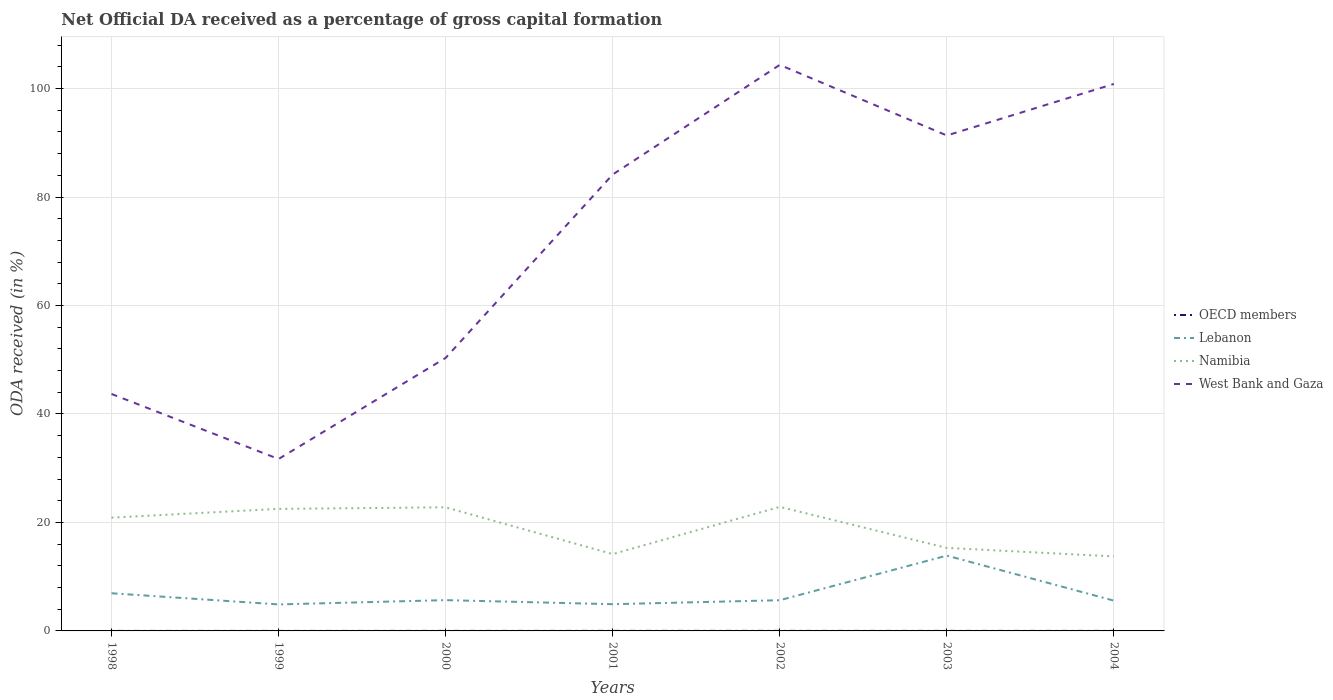How many different coloured lines are there?
Offer a very short reply. 4. Is the number of lines equal to the number of legend labels?
Offer a terse response. Yes. Across all years, what is the maximum net ODA received in OECD members?
Your response must be concise. 0. What is the total net ODA received in West Bank and Gaza in the graph?
Offer a very short reply. 3.51. What is the difference between the highest and the second highest net ODA received in Lebanon?
Keep it short and to the point. 9. Is the net ODA received in West Bank and Gaza strictly greater than the net ODA received in Lebanon over the years?
Provide a short and direct response. No. How many years are there in the graph?
Your response must be concise. 7. What is the difference between two consecutive major ticks on the Y-axis?
Ensure brevity in your answer.  20. Does the graph contain any zero values?
Your answer should be very brief. No. Does the graph contain grids?
Make the answer very short. Yes. Where does the legend appear in the graph?
Provide a short and direct response. Center right. How many legend labels are there?
Keep it short and to the point. 4. What is the title of the graph?
Your answer should be very brief. Net Official DA received as a percentage of gross capital formation. What is the label or title of the X-axis?
Provide a succinct answer. Years. What is the label or title of the Y-axis?
Your answer should be very brief. ODA received (in %). What is the ODA received (in %) in OECD members in 1998?
Make the answer very short. 0. What is the ODA received (in %) of Lebanon in 1998?
Give a very brief answer. 6.94. What is the ODA received (in %) in Namibia in 1998?
Your answer should be very brief. 20.89. What is the ODA received (in %) of West Bank and Gaza in 1998?
Offer a terse response. 43.69. What is the ODA received (in %) in OECD members in 1999?
Offer a terse response. 0. What is the ODA received (in %) of Lebanon in 1999?
Give a very brief answer. 4.88. What is the ODA received (in %) of Namibia in 1999?
Provide a short and direct response. 22.5. What is the ODA received (in %) of West Bank and Gaza in 1999?
Offer a terse response. 31.7. What is the ODA received (in %) in OECD members in 2000?
Provide a short and direct response. 0.01. What is the ODA received (in %) of Lebanon in 2000?
Your response must be concise. 5.68. What is the ODA received (in %) of Namibia in 2000?
Give a very brief answer. 22.79. What is the ODA received (in %) of West Bank and Gaza in 2000?
Your answer should be very brief. 50.34. What is the ODA received (in %) in OECD members in 2001?
Ensure brevity in your answer.  0.01. What is the ODA received (in %) of Lebanon in 2001?
Offer a very short reply. 4.93. What is the ODA received (in %) of Namibia in 2001?
Offer a terse response. 14.17. What is the ODA received (in %) of West Bank and Gaza in 2001?
Offer a very short reply. 84.16. What is the ODA received (in %) in OECD members in 2002?
Ensure brevity in your answer.  0.01. What is the ODA received (in %) of Lebanon in 2002?
Make the answer very short. 5.66. What is the ODA received (in %) of Namibia in 2002?
Your answer should be compact. 22.88. What is the ODA received (in %) of West Bank and Gaza in 2002?
Your response must be concise. 104.37. What is the ODA received (in %) of OECD members in 2003?
Provide a succinct answer. 0.01. What is the ODA received (in %) of Lebanon in 2003?
Your answer should be compact. 13.89. What is the ODA received (in %) in Namibia in 2003?
Keep it short and to the point. 15.3. What is the ODA received (in %) in West Bank and Gaza in 2003?
Keep it short and to the point. 91.35. What is the ODA received (in %) of OECD members in 2004?
Provide a succinct answer. 0.01. What is the ODA received (in %) in Lebanon in 2004?
Make the answer very short. 5.58. What is the ODA received (in %) in Namibia in 2004?
Offer a terse response. 13.74. What is the ODA received (in %) in West Bank and Gaza in 2004?
Offer a very short reply. 100.86. Across all years, what is the maximum ODA received (in %) in OECD members?
Give a very brief answer. 0.01. Across all years, what is the maximum ODA received (in %) of Lebanon?
Ensure brevity in your answer.  13.89. Across all years, what is the maximum ODA received (in %) of Namibia?
Your answer should be very brief. 22.88. Across all years, what is the maximum ODA received (in %) in West Bank and Gaza?
Make the answer very short. 104.37. Across all years, what is the minimum ODA received (in %) of OECD members?
Keep it short and to the point. 0. Across all years, what is the minimum ODA received (in %) in Lebanon?
Give a very brief answer. 4.88. Across all years, what is the minimum ODA received (in %) of Namibia?
Provide a short and direct response. 13.74. Across all years, what is the minimum ODA received (in %) in West Bank and Gaza?
Give a very brief answer. 31.7. What is the total ODA received (in %) of OECD members in the graph?
Keep it short and to the point. 0.04. What is the total ODA received (in %) in Lebanon in the graph?
Keep it short and to the point. 47.56. What is the total ODA received (in %) of Namibia in the graph?
Offer a very short reply. 132.27. What is the total ODA received (in %) of West Bank and Gaza in the graph?
Offer a terse response. 506.46. What is the difference between the ODA received (in %) of OECD members in 1998 and that in 1999?
Offer a very short reply. 0. What is the difference between the ODA received (in %) of Lebanon in 1998 and that in 1999?
Ensure brevity in your answer.  2.06. What is the difference between the ODA received (in %) of Namibia in 1998 and that in 1999?
Keep it short and to the point. -1.61. What is the difference between the ODA received (in %) of West Bank and Gaza in 1998 and that in 1999?
Your response must be concise. 11.99. What is the difference between the ODA received (in %) of OECD members in 1998 and that in 2000?
Offer a terse response. -0. What is the difference between the ODA received (in %) in Lebanon in 1998 and that in 2000?
Make the answer very short. 1.27. What is the difference between the ODA received (in %) in Namibia in 1998 and that in 2000?
Make the answer very short. -1.9. What is the difference between the ODA received (in %) of West Bank and Gaza in 1998 and that in 2000?
Keep it short and to the point. -6.65. What is the difference between the ODA received (in %) in OECD members in 1998 and that in 2001?
Your answer should be compact. -0.01. What is the difference between the ODA received (in %) of Lebanon in 1998 and that in 2001?
Keep it short and to the point. 2.02. What is the difference between the ODA received (in %) in Namibia in 1998 and that in 2001?
Your response must be concise. 6.72. What is the difference between the ODA received (in %) of West Bank and Gaza in 1998 and that in 2001?
Provide a short and direct response. -40.47. What is the difference between the ODA received (in %) of OECD members in 1998 and that in 2002?
Offer a very short reply. -0. What is the difference between the ODA received (in %) in Lebanon in 1998 and that in 2002?
Give a very brief answer. 1.28. What is the difference between the ODA received (in %) of Namibia in 1998 and that in 2002?
Offer a very short reply. -1.99. What is the difference between the ODA received (in %) in West Bank and Gaza in 1998 and that in 2002?
Give a very brief answer. -60.68. What is the difference between the ODA received (in %) in OECD members in 1998 and that in 2003?
Keep it short and to the point. -0. What is the difference between the ODA received (in %) in Lebanon in 1998 and that in 2003?
Give a very brief answer. -6.94. What is the difference between the ODA received (in %) in Namibia in 1998 and that in 2003?
Offer a very short reply. 5.59. What is the difference between the ODA received (in %) in West Bank and Gaza in 1998 and that in 2003?
Your answer should be compact. -47.66. What is the difference between the ODA received (in %) in OECD members in 1998 and that in 2004?
Your answer should be very brief. -0. What is the difference between the ODA received (in %) in Lebanon in 1998 and that in 2004?
Your answer should be very brief. 1.36. What is the difference between the ODA received (in %) of Namibia in 1998 and that in 2004?
Make the answer very short. 7.15. What is the difference between the ODA received (in %) of West Bank and Gaza in 1998 and that in 2004?
Keep it short and to the point. -57.17. What is the difference between the ODA received (in %) of OECD members in 1999 and that in 2000?
Provide a short and direct response. -0. What is the difference between the ODA received (in %) of Lebanon in 1999 and that in 2000?
Your answer should be very brief. -0.79. What is the difference between the ODA received (in %) of Namibia in 1999 and that in 2000?
Keep it short and to the point. -0.29. What is the difference between the ODA received (in %) in West Bank and Gaza in 1999 and that in 2000?
Keep it short and to the point. -18.64. What is the difference between the ODA received (in %) of OECD members in 1999 and that in 2001?
Provide a succinct answer. -0.01. What is the difference between the ODA received (in %) in Lebanon in 1999 and that in 2001?
Make the answer very short. -0.04. What is the difference between the ODA received (in %) in Namibia in 1999 and that in 2001?
Make the answer very short. 8.34. What is the difference between the ODA received (in %) in West Bank and Gaza in 1999 and that in 2001?
Provide a short and direct response. -52.46. What is the difference between the ODA received (in %) of OECD members in 1999 and that in 2002?
Ensure brevity in your answer.  -0.01. What is the difference between the ODA received (in %) of Lebanon in 1999 and that in 2002?
Provide a short and direct response. -0.78. What is the difference between the ODA received (in %) in Namibia in 1999 and that in 2002?
Make the answer very short. -0.37. What is the difference between the ODA received (in %) in West Bank and Gaza in 1999 and that in 2002?
Provide a succinct answer. -72.67. What is the difference between the ODA received (in %) in OECD members in 1999 and that in 2003?
Offer a terse response. -0. What is the difference between the ODA received (in %) in Lebanon in 1999 and that in 2003?
Give a very brief answer. -9. What is the difference between the ODA received (in %) in Namibia in 1999 and that in 2003?
Your answer should be compact. 7.2. What is the difference between the ODA received (in %) of West Bank and Gaza in 1999 and that in 2003?
Make the answer very short. -59.65. What is the difference between the ODA received (in %) of OECD members in 1999 and that in 2004?
Give a very brief answer. -0. What is the difference between the ODA received (in %) of Lebanon in 1999 and that in 2004?
Your answer should be compact. -0.7. What is the difference between the ODA received (in %) in Namibia in 1999 and that in 2004?
Keep it short and to the point. 8.76. What is the difference between the ODA received (in %) of West Bank and Gaza in 1999 and that in 2004?
Your response must be concise. -69.16. What is the difference between the ODA received (in %) in OECD members in 2000 and that in 2001?
Ensure brevity in your answer.  -0. What is the difference between the ODA received (in %) in Lebanon in 2000 and that in 2001?
Offer a very short reply. 0.75. What is the difference between the ODA received (in %) in Namibia in 2000 and that in 2001?
Give a very brief answer. 8.62. What is the difference between the ODA received (in %) in West Bank and Gaza in 2000 and that in 2001?
Offer a very short reply. -33.82. What is the difference between the ODA received (in %) in OECD members in 2000 and that in 2002?
Make the answer very short. -0. What is the difference between the ODA received (in %) in Lebanon in 2000 and that in 2002?
Give a very brief answer. 0.02. What is the difference between the ODA received (in %) of Namibia in 2000 and that in 2002?
Your answer should be very brief. -0.09. What is the difference between the ODA received (in %) of West Bank and Gaza in 2000 and that in 2002?
Ensure brevity in your answer.  -54.03. What is the difference between the ODA received (in %) of OECD members in 2000 and that in 2003?
Your response must be concise. 0. What is the difference between the ODA received (in %) in Lebanon in 2000 and that in 2003?
Offer a very short reply. -8.21. What is the difference between the ODA received (in %) of Namibia in 2000 and that in 2003?
Make the answer very short. 7.49. What is the difference between the ODA received (in %) of West Bank and Gaza in 2000 and that in 2003?
Offer a terse response. -41.01. What is the difference between the ODA received (in %) of OECD members in 2000 and that in 2004?
Make the answer very short. 0. What is the difference between the ODA received (in %) in Lebanon in 2000 and that in 2004?
Make the answer very short. 0.1. What is the difference between the ODA received (in %) of Namibia in 2000 and that in 2004?
Keep it short and to the point. 9.05. What is the difference between the ODA received (in %) in West Bank and Gaza in 2000 and that in 2004?
Your response must be concise. -50.52. What is the difference between the ODA received (in %) in Lebanon in 2001 and that in 2002?
Your answer should be compact. -0.73. What is the difference between the ODA received (in %) in Namibia in 2001 and that in 2002?
Your response must be concise. -8.71. What is the difference between the ODA received (in %) in West Bank and Gaza in 2001 and that in 2002?
Keep it short and to the point. -20.21. What is the difference between the ODA received (in %) of OECD members in 2001 and that in 2003?
Ensure brevity in your answer.  0. What is the difference between the ODA received (in %) of Lebanon in 2001 and that in 2003?
Your answer should be very brief. -8.96. What is the difference between the ODA received (in %) of Namibia in 2001 and that in 2003?
Make the answer very short. -1.14. What is the difference between the ODA received (in %) of West Bank and Gaza in 2001 and that in 2003?
Your response must be concise. -7.19. What is the difference between the ODA received (in %) of OECD members in 2001 and that in 2004?
Offer a very short reply. 0. What is the difference between the ODA received (in %) in Lebanon in 2001 and that in 2004?
Give a very brief answer. -0.65. What is the difference between the ODA received (in %) in Namibia in 2001 and that in 2004?
Offer a very short reply. 0.42. What is the difference between the ODA received (in %) in West Bank and Gaza in 2001 and that in 2004?
Offer a terse response. -16.7. What is the difference between the ODA received (in %) of OECD members in 2002 and that in 2003?
Give a very brief answer. 0. What is the difference between the ODA received (in %) in Lebanon in 2002 and that in 2003?
Make the answer very short. -8.23. What is the difference between the ODA received (in %) of Namibia in 2002 and that in 2003?
Provide a succinct answer. 7.57. What is the difference between the ODA received (in %) of West Bank and Gaza in 2002 and that in 2003?
Provide a succinct answer. 13.02. What is the difference between the ODA received (in %) in OECD members in 2002 and that in 2004?
Offer a very short reply. 0. What is the difference between the ODA received (in %) of Lebanon in 2002 and that in 2004?
Offer a very short reply. 0.08. What is the difference between the ODA received (in %) in Namibia in 2002 and that in 2004?
Provide a succinct answer. 9.13. What is the difference between the ODA received (in %) of West Bank and Gaza in 2002 and that in 2004?
Provide a succinct answer. 3.51. What is the difference between the ODA received (in %) in OECD members in 2003 and that in 2004?
Provide a succinct answer. -0. What is the difference between the ODA received (in %) in Lebanon in 2003 and that in 2004?
Your answer should be very brief. 8.3. What is the difference between the ODA received (in %) in Namibia in 2003 and that in 2004?
Give a very brief answer. 1.56. What is the difference between the ODA received (in %) in West Bank and Gaza in 2003 and that in 2004?
Your answer should be very brief. -9.51. What is the difference between the ODA received (in %) of OECD members in 1998 and the ODA received (in %) of Lebanon in 1999?
Offer a terse response. -4.88. What is the difference between the ODA received (in %) of OECD members in 1998 and the ODA received (in %) of Namibia in 1999?
Your response must be concise. -22.5. What is the difference between the ODA received (in %) in OECD members in 1998 and the ODA received (in %) in West Bank and Gaza in 1999?
Provide a short and direct response. -31.7. What is the difference between the ODA received (in %) of Lebanon in 1998 and the ODA received (in %) of Namibia in 1999?
Offer a very short reply. -15.56. What is the difference between the ODA received (in %) of Lebanon in 1998 and the ODA received (in %) of West Bank and Gaza in 1999?
Offer a terse response. -24.75. What is the difference between the ODA received (in %) of Namibia in 1998 and the ODA received (in %) of West Bank and Gaza in 1999?
Your response must be concise. -10.81. What is the difference between the ODA received (in %) in OECD members in 1998 and the ODA received (in %) in Lebanon in 2000?
Offer a very short reply. -5.67. What is the difference between the ODA received (in %) of OECD members in 1998 and the ODA received (in %) of Namibia in 2000?
Provide a short and direct response. -22.79. What is the difference between the ODA received (in %) of OECD members in 1998 and the ODA received (in %) of West Bank and Gaza in 2000?
Ensure brevity in your answer.  -50.34. What is the difference between the ODA received (in %) in Lebanon in 1998 and the ODA received (in %) in Namibia in 2000?
Ensure brevity in your answer.  -15.85. What is the difference between the ODA received (in %) of Lebanon in 1998 and the ODA received (in %) of West Bank and Gaza in 2000?
Offer a very short reply. -43.39. What is the difference between the ODA received (in %) in Namibia in 1998 and the ODA received (in %) in West Bank and Gaza in 2000?
Offer a terse response. -29.45. What is the difference between the ODA received (in %) of OECD members in 1998 and the ODA received (in %) of Lebanon in 2001?
Provide a succinct answer. -4.93. What is the difference between the ODA received (in %) of OECD members in 1998 and the ODA received (in %) of Namibia in 2001?
Provide a short and direct response. -14.16. What is the difference between the ODA received (in %) in OECD members in 1998 and the ODA received (in %) in West Bank and Gaza in 2001?
Provide a short and direct response. -84.15. What is the difference between the ODA received (in %) of Lebanon in 1998 and the ODA received (in %) of Namibia in 2001?
Make the answer very short. -7.22. What is the difference between the ODA received (in %) in Lebanon in 1998 and the ODA received (in %) in West Bank and Gaza in 2001?
Provide a short and direct response. -77.21. What is the difference between the ODA received (in %) of Namibia in 1998 and the ODA received (in %) of West Bank and Gaza in 2001?
Ensure brevity in your answer.  -63.27. What is the difference between the ODA received (in %) of OECD members in 1998 and the ODA received (in %) of Lebanon in 2002?
Make the answer very short. -5.66. What is the difference between the ODA received (in %) of OECD members in 1998 and the ODA received (in %) of Namibia in 2002?
Give a very brief answer. -22.87. What is the difference between the ODA received (in %) of OECD members in 1998 and the ODA received (in %) of West Bank and Gaza in 2002?
Your answer should be very brief. -104.37. What is the difference between the ODA received (in %) of Lebanon in 1998 and the ODA received (in %) of Namibia in 2002?
Provide a short and direct response. -15.93. What is the difference between the ODA received (in %) in Lebanon in 1998 and the ODA received (in %) in West Bank and Gaza in 2002?
Provide a succinct answer. -97.43. What is the difference between the ODA received (in %) in Namibia in 1998 and the ODA received (in %) in West Bank and Gaza in 2002?
Give a very brief answer. -83.48. What is the difference between the ODA received (in %) of OECD members in 1998 and the ODA received (in %) of Lebanon in 2003?
Provide a short and direct response. -13.88. What is the difference between the ODA received (in %) in OECD members in 1998 and the ODA received (in %) in Namibia in 2003?
Keep it short and to the point. -15.3. What is the difference between the ODA received (in %) of OECD members in 1998 and the ODA received (in %) of West Bank and Gaza in 2003?
Provide a short and direct response. -91.35. What is the difference between the ODA received (in %) in Lebanon in 1998 and the ODA received (in %) in Namibia in 2003?
Your answer should be compact. -8.36. What is the difference between the ODA received (in %) of Lebanon in 1998 and the ODA received (in %) of West Bank and Gaza in 2003?
Provide a succinct answer. -84.41. What is the difference between the ODA received (in %) in Namibia in 1998 and the ODA received (in %) in West Bank and Gaza in 2003?
Give a very brief answer. -70.46. What is the difference between the ODA received (in %) of OECD members in 1998 and the ODA received (in %) of Lebanon in 2004?
Give a very brief answer. -5.58. What is the difference between the ODA received (in %) in OECD members in 1998 and the ODA received (in %) in Namibia in 2004?
Give a very brief answer. -13.74. What is the difference between the ODA received (in %) in OECD members in 1998 and the ODA received (in %) in West Bank and Gaza in 2004?
Ensure brevity in your answer.  -100.85. What is the difference between the ODA received (in %) of Lebanon in 1998 and the ODA received (in %) of Namibia in 2004?
Your answer should be very brief. -6.8. What is the difference between the ODA received (in %) of Lebanon in 1998 and the ODA received (in %) of West Bank and Gaza in 2004?
Your answer should be compact. -93.91. What is the difference between the ODA received (in %) in Namibia in 1998 and the ODA received (in %) in West Bank and Gaza in 2004?
Your response must be concise. -79.97. What is the difference between the ODA received (in %) in OECD members in 1999 and the ODA received (in %) in Lebanon in 2000?
Your answer should be compact. -5.68. What is the difference between the ODA received (in %) in OECD members in 1999 and the ODA received (in %) in Namibia in 2000?
Keep it short and to the point. -22.79. What is the difference between the ODA received (in %) in OECD members in 1999 and the ODA received (in %) in West Bank and Gaza in 2000?
Give a very brief answer. -50.34. What is the difference between the ODA received (in %) of Lebanon in 1999 and the ODA received (in %) of Namibia in 2000?
Offer a very short reply. -17.91. What is the difference between the ODA received (in %) in Lebanon in 1999 and the ODA received (in %) in West Bank and Gaza in 2000?
Ensure brevity in your answer.  -45.45. What is the difference between the ODA received (in %) of Namibia in 1999 and the ODA received (in %) of West Bank and Gaza in 2000?
Give a very brief answer. -27.84. What is the difference between the ODA received (in %) in OECD members in 1999 and the ODA received (in %) in Lebanon in 2001?
Your answer should be very brief. -4.93. What is the difference between the ODA received (in %) of OECD members in 1999 and the ODA received (in %) of Namibia in 2001?
Provide a short and direct response. -14.16. What is the difference between the ODA received (in %) of OECD members in 1999 and the ODA received (in %) of West Bank and Gaza in 2001?
Keep it short and to the point. -84.15. What is the difference between the ODA received (in %) of Lebanon in 1999 and the ODA received (in %) of Namibia in 2001?
Keep it short and to the point. -9.28. What is the difference between the ODA received (in %) in Lebanon in 1999 and the ODA received (in %) in West Bank and Gaza in 2001?
Your answer should be very brief. -79.27. What is the difference between the ODA received (in %) in Namibia in 1999 and the ODA received (in %) in West Bank and Gaza in 2001?
Keep it short and to the point. -61.65. What is the difference between the ODA received (in %) in OECD members in 1999 and the ODA received (in %) in Lebanon in 2002?
Your answer should be compact. -5.66. What is the difference between the ODA received (in %) in OECD members in 1999 and the ODA received (in %) in Namibia in 2002?
Make the answer very short. -22.88. What is the difference between the ODA received (in %) of OECD members in 1999 and the ODA received (in %) of West Bank and Gaza in 2002?
Ensure brevity in your answer.  -104.37. What is the difference between the ODA received (in %) of Lebanon in 1999 and the ODA received (in %) of Namibia in 2002?
Give a very brief answer. -17.99. What is the difference between the ODA received (in %) of Lebanon in 1999 and the ODA received (in %) of West Bank and Gaza in 2002?
Provide a succinct answer. -99.48. What is the difference between the ODA received (in %) of Namibia in 1999 and the ODA received (in %) of West Bank and Gaza in 2002?
Your response must be concise. -81.87. What is the difference between the ODA received (in %) in OECD members in 1999 and the ODA received (in %) in Lebanon in 2003?
Provide a short and direct response. -13.89. What is the difference between the ODA received (in %) of OECD members in 1999 and the ODA received (in %) of Namibia in 2003?
Your answer should be very brief. -15.3. What is the difference between the ODA received (in %) of OECD members in 1999 and the ODA received (in %) of West Bank and Gaza in 2003?
Offer a very short reply. -91.35. What is the difference between the ODA received (in %) of Lebanon in 1999 and the ODA received (in %) of Namibia in 2003?
Offer a terse response. -10.42. What is the difference between the ODA received (in %) in Lebanon in 1999 and the ODA received (in %) in West Bank and Gaza in 2003?
Give a very brief answer. -86.47. What is the difference between the ODA received (in %) of Namibia in 1999 and the ODA received (in %) of West Bank and Gaza in 2003?
Offer a terse response. -68.85. What is the difference between the ODA received (in %) of OECD members in 1999 and the ODA received (in %) of Lebanon in 2004?
Provide a short and direct response. -5.58. What is the difference between the ODA received (in %) in OECD members in 1999 and the ODA received (in %) in Namibia in 2004?
Give a very brief answer. -13.74. What is the difference between the ODA received (in %) of OECD members in 1999 and the ODA received (in %) of West Bank and Gaza in 2004?
Your response must be concise. -100.85. What is the difference between the ODA received (in %) of Lebanon in 1999 and the ODA received (in %) of Namibia in 2004?
Offer a very short reply. -8.86. What is the difference between the ODA received (in %) in Lebanon in 1999 and the ODA received (in %) in West Bank and Gaza in 2004?
Offer a very short reply. -95.97. What is the difference between the ODA received (in %) of Namibia in 1999 and the ODA received (in %) of West Bank and Gaza in 2004?
Your answer should be compact. -78.35. What is the difference between the ODA received (in %) of OECD members in 2000 and the ODA received (in %) of Lebanon in 2001?
Offer a very short reply. -4.92. What is the difference between the ODA received (in %) of OECD members in 2000 and the ODA received (in %) of Namibia in 2001?
Offer a terse response. -14.16. What is the difference between the ODA received (in %) in OECD members in 2000 and the ODA received (in %) in West Bank and Gaza in 2001?
Your response must be concise. -84.15. What is the difference between the ODA received (in %) of Lebanon in 2000 and the ODA received (in %) of Namibia in 2001?
Ensure brevity in your answer.  -8.49. What is the difference between the ODA received (in %) of Lebanon in 2000 and the ODA received (in %) of West Bank and Gaza in 2001?
Ensure brevity in your answer.  -78.48. What is the difference between the ODA received (in %) in Namibia in 2000 and the ODA received (in %) in West Bank and Gaza in 2001?
Your answer should be very brief. -61.37. What is the difference between the ODA received (in %) in OECD members in 2000 and the ODA received (in %) in Lebanon in 2002?
Your answer should be compact. -5.66. What is the difference between the ODA received (in %) of OECD members in 2000 and the ODA received (in %) of Namibia in 2002?
Ensure brevity in your answer.  -22.87. What is the difference between the ODA received (in %) of OECD members in 2000 and the ODA received (in %) of West Bank and Gaza in 2002?
Give a very brief answer. -104.36. What is the difference between the ODA received (in %) of Lebanon in 2000 and the ODA received (in %) of Namibia in 2002?
Give a very brief answer. -17.2. What is the difference between the ODA received (in %) of Lebanon in 2000 and the ODA received (in %) of West Bank and Gaza in 2002?
Your answer should be very brief. -98.69. What is the difference between the ODA received (in %) of Namibia in 2000 and the ODA received (in %) of West Bank and Gaza in 2002?
Your response must be concise. -81.58. What is the difference between the ODA received (in %) in OECD members in 2000 and the ODA received (in %) in Lebanon in 2003?
Keep it short and to the point. -13.88. What is the difference between the ODA received (in %) in OECD members in 2000 and the ODA received (in %) in Namibia in 2003?
Ensure brevity in your answer.  -15.3. What is the difference between the ODA received (in %) of OECD members in 2000 and the ODA received (in %) of West Bank and Gaza in 2003?
Make the answer very short. -91.34. What is the difference between the ODA received (in %) in Lebanon in 2000 and the ODA received (in %) in Namibia in 2003?
Your answer should be compact. -9.63. What is the difference between the ODA received (in %) of Lebanon in 2000 and the ODA received (in %) of West Bank and Gaza in 2003?
Ensure brevity in your answer.  -85.67. What is the difference between the ODA received (in %) in Namibia in 2000 and the ODA received (in %) in West Bank and Gaza in 2003?
Make the answer very short. -68.56. What is the difference between the ODA received (in %) in OECD members in 2000 and the ODA received (in %) in Lebanon in 2004?
Your response must be concise. -5.58. What is the difference between the ODA received (in %) in OECD members in 2000 and the ODA received (in %) in Namibia in 2004?
Your response must be concise. -13.74. What is the difference between the ODA received (in %) in OECD members in 2000 and the ODA received (in %) in West Bank and Gaza in 2004?
Your answer should be very brief. -100.85. What is the difference between the ODA received (in %) of Lebanon in 2000 and the ODA received (in %) of Namibia in 2004?
Give a very brief answer. -8.06. What is the difference between the ODA received (in %) of Lebanon in 2000 and the ODA received (in %) of West Bank and Gaza in 2004?
Your response must be concise. -95.18. What is the difference between the ODA received (in %) in Namibia in 2000 and the ODA received (in %) in West Bank and Gaza in 2004?
Offer a terse response. -78.07. What is the difference between the ODA received (in %) of OECD members in 2001 and the ODA received (in %) of Lebanon in 2002?
Make the answer very short. -5.65. What is the difference between the ODA received (in %) in OECD members in 2001 and the ODA received (in %) in Namibia in 2002?
Provide a succinct answer. -22.87. What is the difference between the ODA received (in %) of OECD members in 2001 and the ODA received (in %) of West Bank and Gaza in 2002?
Your answer should be very brief. -104.36. What is the difference between the ODA received (in %) in Lebanon in 2001 and the ODA received (in %) in Namibia in 2002?
Offer a very short reply. -17.95. What is the difference between the ODA received (in %) of Lebanon in 2001 and the ODA received (in %) of West Bank and Gaza in 2002?
Offer a very short reply. -99.44. What is the difference between the ODA received (in %) in Namibia in 2001 and the ODA received (in %) in West Bank and Gaza in 2002?
Ensure brevity in your answer.  -90.2. What is the difference between the ODA received (in %) of OECD members in 2001 and the ODA received (in %) of Lebanon in 2003?
Offer a very short reply. -13.88. What is the difference between the ODA received (in %) in OECD members in 2001 and the ODA received (in %) in Namibia in 2003?
Provide a succinct answer. -15.3. What is the difference between the ODA received (in %) of OECD members in 2001 and the ODA received (in %) of West Bank and Gaza in 2003?
Offer a very short reply. -91.34. What is the difference between the ODA received (in %) of Lebanon in 2001 and the ODA received (in %) of Namibia in 2003?
Make the answer very short. -10.38. What is the difference between the ODA received (in %) in Lebanon in 2001 and the ODA received (in %) in West Bank and Gaza in 2003?
Provide a succinct answer. -86.42. What is the difference between the ODA received (in %) of Namibia in 2001 and the ODA received (in %) of West Bank and Gaza in 2003?
Provide a short and direct response. -77.19. What is the difference between the ODA received (in %) of OECD members in 2001 and the ODA received (in %) of Lebanon in 2004?
Offer a very short reply. -5.57. What is the difference between the ODA received (in %) in OECD members in 2001 and the ODA received (in %) in Namibia in 2004?
Provide a short and direct response. -13.73. What is the difference between the ODA received (in %) of OECD members in 2001 and the ODA received (in %) of West Bank and Gaza in 2004?
Make the answer very short. -100.85. What is the difference between the ODA received (in %) of Lebanon in 2001 and the ODA received (in %) of Namibia in 2004?
Your answer should be very brief. -8.81. What is the difference between the ODA received (in %) in Lebanon in 2001 and the ODA received (in %) in West Bank and Gaza in 2004?
Make the answer very short. -95.93. What is the difference between the ODA received (in %) in Namibia in 2001 and the ODA received (in %) in West Bank and Gaza in 2004?
Give a very brief answer. -86.69. What is the difference between the ODA received (in %) of OECD members in 2002 and the ODA received (in %) of Lebanon in 2003?
Your answer should be compact. -13.88. What is the difference between the ODA received (in %) of OECD members in 2002 and the ODA received (in %) of Namibia in 2003?
Ensure brevity in your answer.  -15.3. What is the difference between the ODA received (in %) of OECD members in 2002 and the ODA received (in %) of West Bank and Gaza in 2003?
Give a very brief answer. -91.34. What is the difference between the ODA received (in %) in Lebanon in 2002 and the ODA received (in %) in Namibia in 2003?
Provide a succinct answer. -9.64. What is the difference between the ODA received (in %) in Lebanon in 2002 and the ODA received (in %) in West Bank and Gaza in 2003?
Your answer should be compact. -85.69. What is the difference between the ODA received (in %) in Namibia in 2002 and the ODA received (in %) in West Bank and Gaza in 2003?
Give a very brief answer. -68.47. What is the difference between the ODA received (in %) in OECD members in 2002 and the ODA received (in %) in Lebanon in 2004?
Your response must be concise. -5.57. What is the difference between the ODA received (in %) of OECD members in 2002 and the ODA received (in %) of Namibia in 2004?
Provide a succinct answer. -13.73. What is the difference between the ODA received (in %) in OECD members in 2002 and the ODA received (in %) in West Bank and Gaza in 2004?
Offer a very short reply. -100.85. What is the difference between the ODA received (in %) of Lebanon in 2002 and the ODA received (in %) of Namibia in 2004?
Ensure brevity in your answer.  -8.08. What is the difference between the ODA received (in %) in Lebanon in 2002 and the ODA received (in %) in West Bank and Gaza in 2004?
Give a very brief answer. -95.2. What is the difference between the ODA received (in %) of Namibia in 2002 and the ODA received (in %) of West Bank and Gaza in 2004?
Make the answer very short. -77.98. What is the difference between the ODA received (in %) in OECD members in 2003 and the ODA received (in %) in Lebanon in 2004?
Provide a short and direct response. -5.58. What is the difference between the ODA received (in %) of OECD members in 2003 and the ODA received (in %) of Namibia in 2004?
Your answer should be compact. -13.74. What is the difference between the ODA received (in %) in OECD members in 2003 and the ODA received (in %) in West Bank and Gaza in 2004?
Provide a short and direct response. -100.85. What is the difference between the ODA received (in %) of Lebanon in 2003 and the ODA received (in %) of Namibia in 2004?
Your answer should be compact. 0.15. What is the difference between the ODA received (in %) of Lebanon in 2003 and the ODA received (in %) of West Bank and Gaza in 2004?
Ensure brevity in your answer.  -86.97. What is the difference between the ODA received (in %) in Namibia in 2003 and the ODA received (in %) in West Bank and Gaza in 2004?
Offer a very short reply. -85.55. What is the average ODA received (in %) in OECD members per year?
Provide a succinct answer. 0.01. What is the average ODA received (in %) in Lebanon per year?
Provide a succinct answer. 6.79. What is the average ODA received (in %) in Namibia per year?
Your answer should be compact. 18.9. What is the average ODA received (in %) of West Bank and Gaza per year?
Offer a very short reply. 72.35. In the year 1998, what is the difference between the ODA received (in %) of OECD members and ODA received (in %) of Lebanon?
Ensure brevity in your answer.  -6.94. In the year 1998, what is the difference between the ODA received (in %) of OECD members and ODA received (in %) of Namibia?
Your answer should be very brief. -20.89. In the year 1998, what is the difference between the ODA received (in %) in OECD members and ODA received (in %) in West Bank and Gaza?
Offer a terse response. -43.69. In the year 1998, what is the difference between the ODA received (in %) of Lebanon and ODA received (in %) of Namibia?
Your response must be concise. -13.95. In the year 1998, what is the difference between the ODA received (in %) in Lebanon and ODA received (in %) in West Bank and Gaza?
Offer a terse response. -36.75. In the year 1998, what is the difference between the ODA received (in %) in Namibia and ODA received (in %) in West Bank and Gaza?
Keep it short and to the point. -22.8. In the year 1999, what is the difference between the ODA received (in %) of OECD members and ODA received (in %) of Lebanon?
Your answer should be compact. -4.88. In the year 1999, what is the difference between the ODA received (in %) of OECD members and ODA received (in %) of Namibia?
Offer a terse response. -22.5. In the year 1999, what is the difference between the ODA received (in %) in OECD members and ODA received (in %) in West Bank and Gaza?
Your response must be concise. -31.7. In the year 1999, what is the difference between the ODA received (in %) in Lebanon and ODA received (in %) in Namibia?
Make the answer very short. -17.62. In the year 1999, what is the difference between the ODA received (in %) in Lebanon and ODA received (in %) in West Bank and Gaza?
Provide a succinct answer. -26.81. In the year 1999, what is the difference between the ODA received (in %) in Namibia and ODA received (in %) in West Bank and Gaza?
Provide a succinct answer. -9.2. In the year 2000, what is the difference between the ODA received (in %) in OECD members and ODA received (in %) in Lebanon?
Your answer should be compact. -5.67. In the year 2000, what is the difference between the ODA received (in %) of OECD members and ODA received (in %) of Namibia?
Your response must be concise. -22.78. In the year 2000, what is the difference between the ODA received (in %) in OECD members and ODA received (in %) in West Bank and Gaza?
Provide a succinct answer. -50.33. In the year 2000, what is the difference between the ODA received (in %) of Lebanon and ODA received (in %) of Namibia?
Keep it short and to the point. -17.11. In the year 2000, what is the difference between the ODA received (in %) of Lebanon and ODA received (in %) of West Bank and Gaza?
Offer a very short reply. -44.66. In the year 2000, what is the difference between the ODA received (in %) in Namibia and ODA received (in %) in West Bank and Gaza?
Your answer should be compact. -27.55. In the year 2001, what is the difference between the ODA received (in %) in OECD members and ODA received (in %) in Lebanon?
Make the answer very short. -4.92. In the year 2001, what is the difference between the ODA received (in %) in OECD members and ODA received (in %) in Namibia?
Give a very brief answer. -14.16. In the year 2001, what is the difference between the ODA received (in %) of OECD members and ODA received (in %) of West Bank and Gaza?
Give a very brief answer. -84.15. In the year 2001, what is the difference between the ODA received (in %) of Lebanon and ODA received (in %) of Namibia?
Provide a short and direct response. -9.24. In the year 2001, what is the difference between the ODA received (in %) in Lebanon and ODA received (in %) in West Bank and Gaza?
Make the answer very short. -79.23. In the year 2001, what is the difference between the ODA received (in %) in Namibia and ODA received (in %) in West Bank and Gaza?
Offer a very short reply. -69.99. In the year 2002, what is the difference between the ODA received (in %) of OECD members and ODA received (in %) of Lebanon?
Offer a terse response. -5.65. In the year 2002, what is the difference between the ODA received (in %) of OECD members and ODA received (in %) of Namibia?
Your response must be concise. -22.87. In the year 2002, what is the difference between the ODA received (in %) of OECD members and ODA received (in %) of West Bank and Gaza?
Provide a short and direct response. -104.36. In the year 2002, what is the difference between the ODA received (in %) of Lebanon and ODA received (in %) of Namibia?
Provide a succinct answer. -17.22. In the year 2002, what is the difference between the ODA received (in %) of Lebanon and ODA received (in %) of West Bank and Gaza?
Provide a succinct answer. -98.71. In the year 2002, what is the difference between the ODA received (in %) of Namibia and ODA received (in %) of West Bank and Gaza?
Give a very brief answer. -81.49. In the year 2003, what is the difference between the ODA received (in %) in OECD members and ODA received (in %) in Lebanon?
Offer a terse response. -13.88. In the year 2003, what is the difference between the ODA received (in %) in OECD members and ODA received (in %) in Namibia?
Your response must be concise. -15.3. In the year 2003, what is the difference between the ODA received (in %) in OECD members and ODA received (in %) in West Bank and Gaza?
Make the answer very short. -91.34. In the year 2003, what is the difference between the ODA received (in %) of Lebanon and ODA received (in %) of Namibia?
Keep it short and to the point. -1.42. In the year 2003, what is the difference between the ODA received (in %) of Lebanon and ODA received (in %) of West Bank and Gaza?
Offer a very short reply. -77.46. In the year 2003, what is the difference between the ODA received (in %) in Namibia and ODA received (in %) in West Bank and Gaza?
Your response must be concise. -76.05. In the year 2004, what is the difference between the ODA received (in %) of OECD members and ODA received (in %) of Lebanon?
Ensure brevity in your answer.  -5.58. In the year 2004, what is the difference between the ODA received (in %) of OECD members and ODA received (in %) of Namibia?
Ensure brevity in your answer.  -13.74. In the year 2004, what is the difference between the ODA received (in %) in OECD members and ODA received (in %) in West Bank and Gaza?
Your response must be concise. -100.85. In the year 2004, what is the difference between the ODA received (in %) of Lebanon and ODA received (in %) of Namibia?
Make the answer very short. -8.16. In the year 2004, what is the difference between the ODA received (in %) of Lebanon and ODA received (in %) of West Bank and Gaza?
Your response must be concise. -95.27. In the year 2004, what is the difference between the ODA received (in %) in Namibia and ODA received (in %) in West Bank and Gaza?
Make the answer very short. -87.11. What is the ratio of the ODA received (in %) in OECD members in 1998 to that in 1999?
Offer a terse response. 1.63. What is the ratio of the ODA received (in %) in Lebanon in 1998 to that in 1999?
Ensure brevity in your answer.  1.42. What is the ratio of the ODA received (in %) in Namibia in 1998 to that in 1999?
Provide a short and direct response. 0.93. What is the ratio of the ODA received (in %) in West Bank and Gaza in 1998 to that in 1999?
Ensure brevity in your answer.  1.38. What is the ratio of the ODA received (in %) of OECD members in 1998 to that in 2000?
Your answer should be compact. 0.41. What is the ratio of the ODA received (in %) of Lebanon in 1998 to that in 2000?
Ensure brevity in your answer.  1.22. What is the ratio of the ODA received (in %) of Namibia in 1998 to that in 2000?
Your response must be concise. 0.92. What is the ratio of the ODA received (in %) in West Bank and Gaza in 1998 to that in 2000?
Ensure brevity in your answer.  0.87. What is the ratio of the ODA received (in %) in OECD members in 1998 to that in 2001?
Provide a short and direct response. 0.33. What is the ratio of the ODA received (in %) in Lebanon in 1998 to that in 2001?
Keep it short and to the point. 1.41. What is the ratio of the ODA received (in %) in Namibia in 1998 to that in 2001?
Your answer should be very brief. 1.47. What is the ratio of the ODA received (in %) of West Bank and Gaza in 1998 to that in 2001?
Keep it short and to the point. 0.52. What is the ratio of the ODA received (in %) in OECD members in 1998 to that in 2002?
Your response must be concise. 0.33. What is the ratio of the ODA received (in %) in Lebanon in 1998 to that in 2002?
Ensure brevity in your answer.  1.23. What is the ratio of the ODA received (in %) of Namibia in 1998 to that in 2002?
Give a very brief answer. 0.91. What is the ratio of the ODA received (in %) of West Bank and Gaza in 1998 to that in 2002?
Offer a very short reply. 0.42. What is the ratio of the ODA received (in %) of OECD members in 1998 to that in 2003?
Give a very brief answer. 0.45. What is the ratio of the ODA received (in %) in Lebanon in 1998 to that in 2003?
Offer a very short reply. 0.5. What is the ratio of the ODA received (in %) of Namibia in 1998 to that in 2003?
Ensure brevity in your answer.  1.37. What is the ratio of the ODA received (in %) of West Bank and Gaza in 1998 to that in 2003?
Provide a succinct answer. 0.48. What is the ratio of the ODA received (in %) in OECD members in 1998 to that in 2004?
Provide a succinct answer. 0.43. What is the ratio of the ODA received (in %) in Lebanon in 1998 to that in 2004?
Your answer should be compact. 1.24. What is the ratio of the ODA received (in %) in Namibia in 1998 to that in 2004?
Offer a terse response. 1.52. What is the ratio of the ODA received (in %) in West Bank and Gaza in 1998 to that in 2004?
Ensure brevity in your answer.  0.43. What is the ratio of the ODA received (in %) in OECD members in 1999 to that in 2000?
Ensure brevity in your answer.  0.25. What is the ratio of the ODA received (in %) of Lebanon in 1999 to that in 2000?
Your answer should be compact. 0.86. What is the ratio of the ODA received (in %) of Namibia in 1999 to that in 2000?
Keep it short and to the point. 0.99. What is the ratio of the ODA received (in %) in West Bank and Gaza in 1999 to that in 2000?
Make the answer very short. 0.63. What is the ratio of the ODA received (in %) in OECD members in 1999 to that in 2001?
Give a very brief answer. 0.2. What is the ratio of the ODA received (in %) of Namibia in 1999 to that in 2001?
Offer a very short reply. 1.59. What is the ratio of the ODA received (in %) of West Bank and Gaza in 1999 to that in 2001?
Give a very brief answer. 0.38. What is the ratio of the ODA received (in %) in OECD members in 1999 to that in 2002?
Offer a very short reply. 0.2. What is the ratio of the ODA received (in %) in Lebanon in 1999 to that in 2002?
Provide a succinct answer. 0.86. What is the ratio of the ODA received (in %) of Namibia in 1999 to that in 2002?
Your response must be concise. 0.98. What is the ratio of the ODA received (in %) of West Bank and Gaza in 1999 to that in 2002?
Keep it short and to the point. 0.3. What is the ratio of the ODA received (in %) in OECD members in 1999 to that in 2003?
Provide a succinct answer. 0.28. What is the ratio of the ODA received (in %) in Lebanon in 1999 to that in 2003?
Offer a terse response. 0.35. What is the ratio of the ODA received (in %) in Namibia in 1999 to that in 2003?
Give a very brief answer. 1.47. What is the ratio of the ODA received (in %) of West Bank and Gaza in 1999 to that in 2003?
Provide a succinct answer. 0.35. What is the ratio of the ODA received (in %) of OECD members in 1999 to that in 2004?
Offer a terse response. 0.26. What is the ratio of the ODA received (in %) of Lebanon in 1999 to that in 2004?
Ensure brevity in your answer.  0.88. What is the ratio of the ODA received (in %) in Namibia in 1999 to that in 2004?
Give a very brief answer. 1.64. What is the ratio of the ODA received (in %) in West Bank and Gaza in 1999 to that in 2004?
Offer a terse response. 0.31. What is the ratio of the ODA received (in %) in OECD members in 2000 to that in 2001?
Give a very brief answer. 0.79. What is the ratio of the ODA received (in %) of Lebanon in 2000 to that in 2001?
Your answer should be very brief. 1.15. What is the ratio of the ODA received (in %) of Namibia in 2000 to that in 2001?
Keep it short and to the point. 1.61. What is the ratio of the ODA received (in %) of West Bank and Gaza in 2000 to that in 2001?
Your response must be concise. 0.6. What is the ratio of the ODA received (in %) of OECD members in 2000 to that in 2002?
Provide a succinct answer. 0.8. What is the ratio of the ODA received (in %) in Lebanon in 2000 to that in 2002?
Your answer should be compact. 1. What is the ratio of the ODA received (in %) of Namibia in 2000 to that in 2002?
Keep it short and to the point. 1. What is the ratio of the ODA received (in %) in West Bank and Gaza in 2000 to that in 2002?
Your answer should be very brief. 0.48. What is the ratio of the ODA received (in %) of OECD members in 2000 to that in 2003?
Provide a succinct answer. 1.08. What is the ratio of the ODA received (in %) of Lebanon in 2000 to that in 2003?
Provide a succinct answer. 0.41. What is the ratio of the ODA received (in %) in Namibia in 2000 to that in 2003?
Your answer should be very brief. 1.49. What is the ratio of the ODA received (in %) of West Bank and Gaza in 2000 to that in 2003?
Keep it short and to the point. 0.55. What is the ratio of the ODA received (in %) of OECD members in 2000 to that in 2004?
Provide a short and direct response. 1.03. What is the ratio of the ODA received (in %) of Lebanon in 2000 to that in 2004?
Make the answer very short. 1.02. What is the ratio of the ODA received (in %) in Namibia in 2000 to that in 2004?
Your answer should be compact. 1.66. What is the ratio of the ODA received (in %) in West Bank and Gaza in 2000 to that in 2004?
Your response must be concise. 0.5. What is the ratio of the ODA received (in %) of OECD members in 2001 to that in 2002?
Your answer should be compact. 1.01. What is the ratio of the ODA received (in %) in Lebanon in 2001 to that in 2002?
Your response must be concise. 0.87. What is the ratio of the ODA received (in %) of Namibia in 2001 to that in 2002?
Make the answer very short. 0.62. What is the ratio of the ODA received (in %) of West Bank and Gaza in 2001 to that in 2002?
Offer a terse response. 0.81. What is the ratio of the ODA received (in %) in OECD members in 2001 to that in 2003?
Keep it short and to the point. 1.37. What is the ratio of the ODA received (in %) of Lebanon in 2001 to that in 2003?
Provide a succinct answer. 0.35. What is the ratio of the ODA received (in %) of Namibia in 2001 to that in 2003?
Your answer should be compact. 0.93. What is the ratio of the ODA received (in %) in West Bank and Gaza in 2001 to that in 2003?
Provide a succinct answer. 0.92. What is the ratio of the ODA received (in %) in OECD members in 2001 to that in 2004?
Make the answer very short. 1.3. What is the ratio of the ODA received (in %) of Lebanon in 2001 to that in 2004?
Provide a succinct answer. 0.88. What is the ratio of the ODA received (in %) in Namibia in 2001 to that in 2004?
Provide a succinct answer. 1.03. What is the ratio of the ODA received (in %) in West Bank and Gaza in 2001 to that in 2004?
Ensure brevity in your answer.  0.83. What is the ratio of the ODA received (in %) in OECD members in 2002 to that in 2003?
Offer a very short reply. 1.36. What is the ratio of the ODA received (in %) in Lebanon in 2002 to that in 2003?
Provide a succinct answer. 0.41. What is the ratio of the ODA received (in %) in Namibia in 2002 to that in 2003?
Ensure brevity in your answer.  1.49. What is the ratio of the ODA received (in %) of West Bank and Gaza in 2002 to that in 2003?
Your answer should be compact. 1.14. What is the ratio of the ODA received (in %) of OECD members in 2002 to that in 2004?
Offer a terse response. 1.28. What is the ratio of the ODA received (in %) in Lebanon in 2002 to that in 2004?
Give a very brief answer. 1.01. What is the ratio of the ODA received (in %) of Namibia in 2002 to that in 2004?
Provide a succinct answer. 1.66. What is the ratio of the ODA received (in %) in West Bank and Gaza in 2002 to that in 2004?
Your answer should be compact. 1.03. What is the ratio of the ODA received (in %) of OECD members in 2003 to that in 2004?
Your answer should be very brief. 0.95. What is the ratio of the ODA received (in %) of Lebanon in 2003 to that in 2004?
Give a very brief answer. 2.49. What is the ratio of the ODA received (in %) of Namibia in 2003 to that in 2004?
Make the answer very short. 1.11. What is the ratio of the ODA received (in %) of West Bank and Gaza in 2003 to that in 2004?
Give a very brief answer. 0.91. What is the difference between the highest and the second highest ODA received (in %) of OECD members?
Give a very brief answer. 0. What is the difference between the highest and the second highest ODA received (in %) in Lebanon?
Offer a very short reply. 6.94. What is the difference between the highest and the second highest ODA received (in %) in Namibia?
Your response must be concise. 0.09. What is the difference between the highest and the second highest ODA received (in %) in West Bank and Gaza?
Give a very brief answer. 3.51. What is the difference between the highest and the lowest ODA received (in %) in OECD members?
Your response must be concise. 0.01. What is the difference between the highest and the lowest ODA received (in %) of Lebanon?
Keep it short and to the point. 9. What is the difference between the highest and the lowest ODA received (in %) in Namibia?
Your response must be concise. 9.13. What is the difference between the highest and the lowest ODA received (in %) of West Bank and Gaza?
Provide a short and direct response. 72.67. 